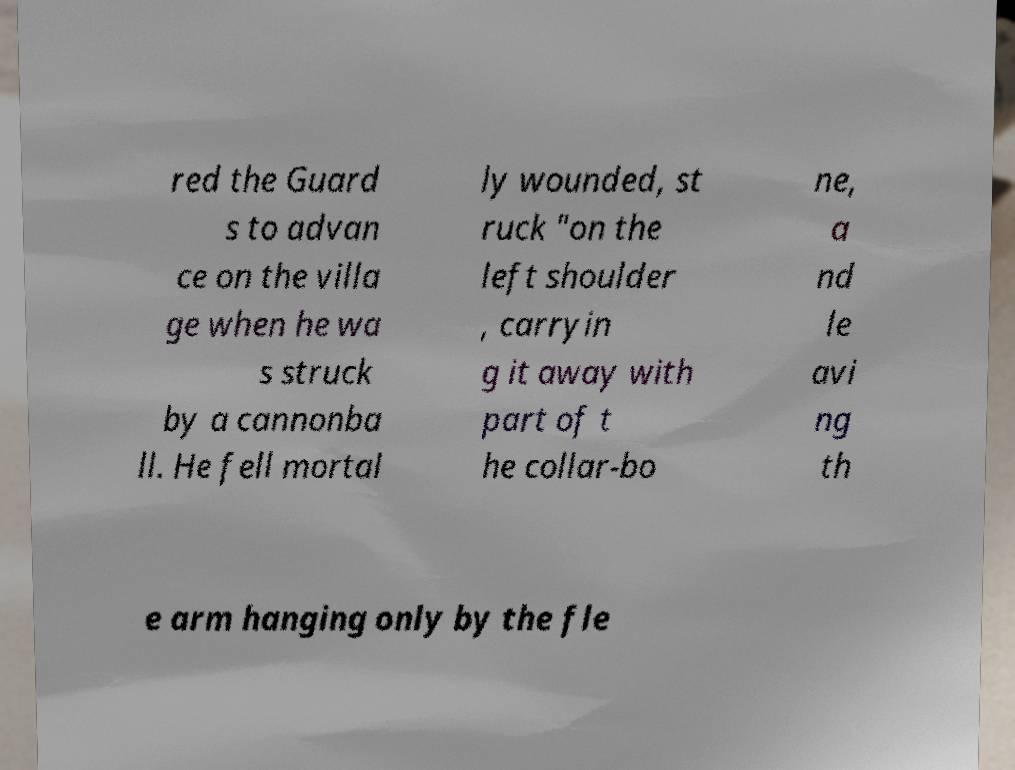Could you extract and type out the text from this image? red the Guard s to advan ce on the villa ge when he wa s struck by a cannonba ll. He fell mortal ly wounded, st ruck "on the left shoulder , carryin g it away with part of t he collar-bo ne, a nd le avi ng th e arm hanging only by the fle 